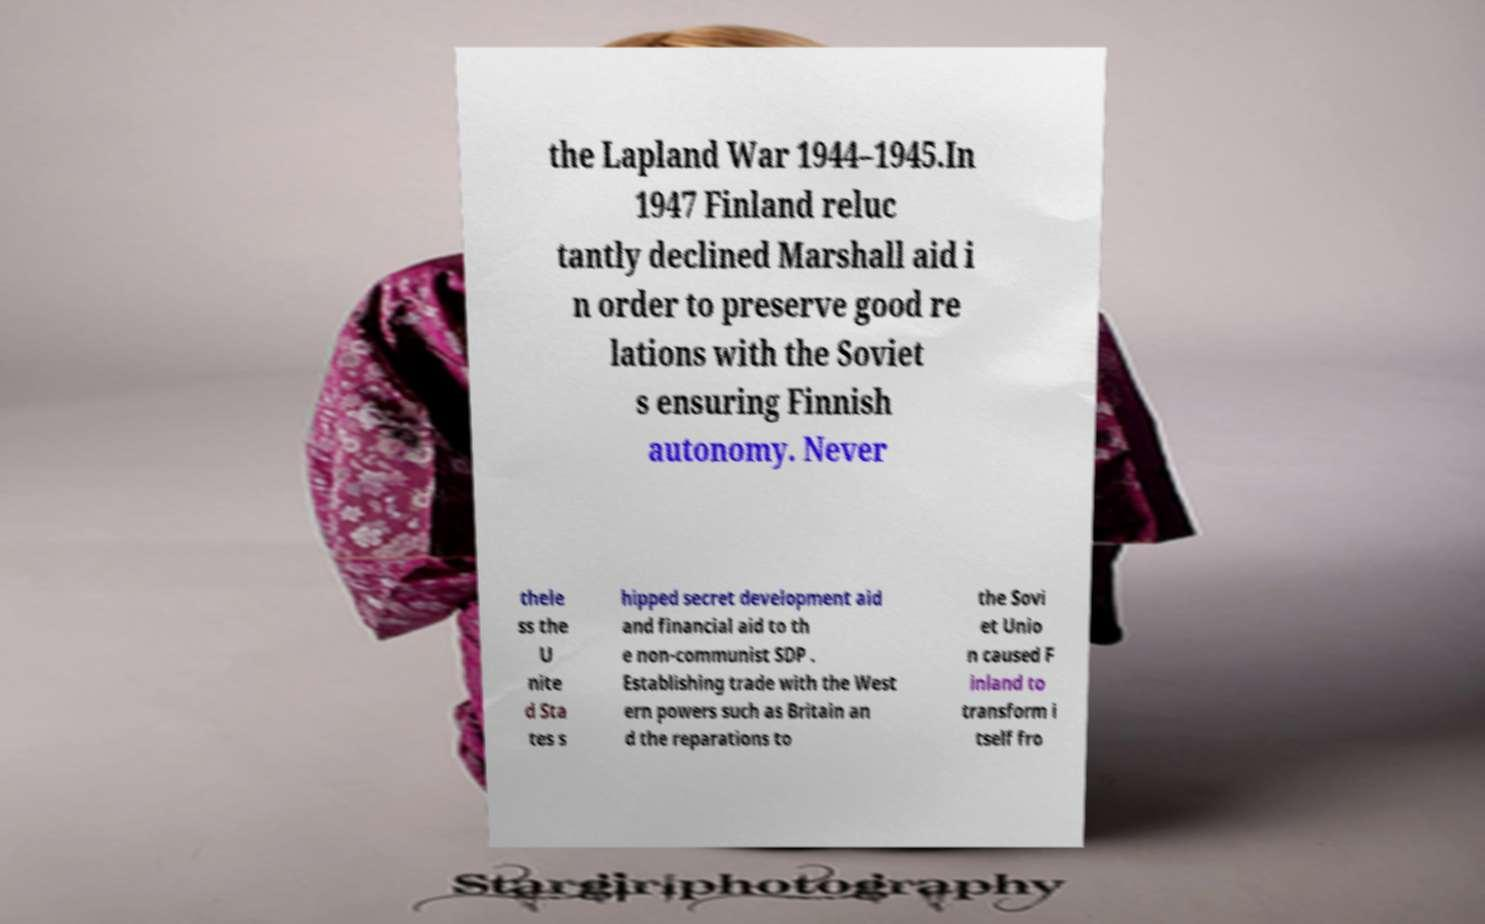I need the written content from this picture converted into text. Can you do that? the Lapland War 1944–1945.In 1947 Finland reluc tantly declined Marshall aid i n order to preserve good re lations with the Soviet s ensuring Finnish autonomy. Never thele ss the U nite d Sta tes s hipped secret development aid and financial aid to th e non-communist SDP . Establishing trade with the West ern powers such as Britain an d the reparations to the Sovi et Unio n caused F inland to transform i tself fro 